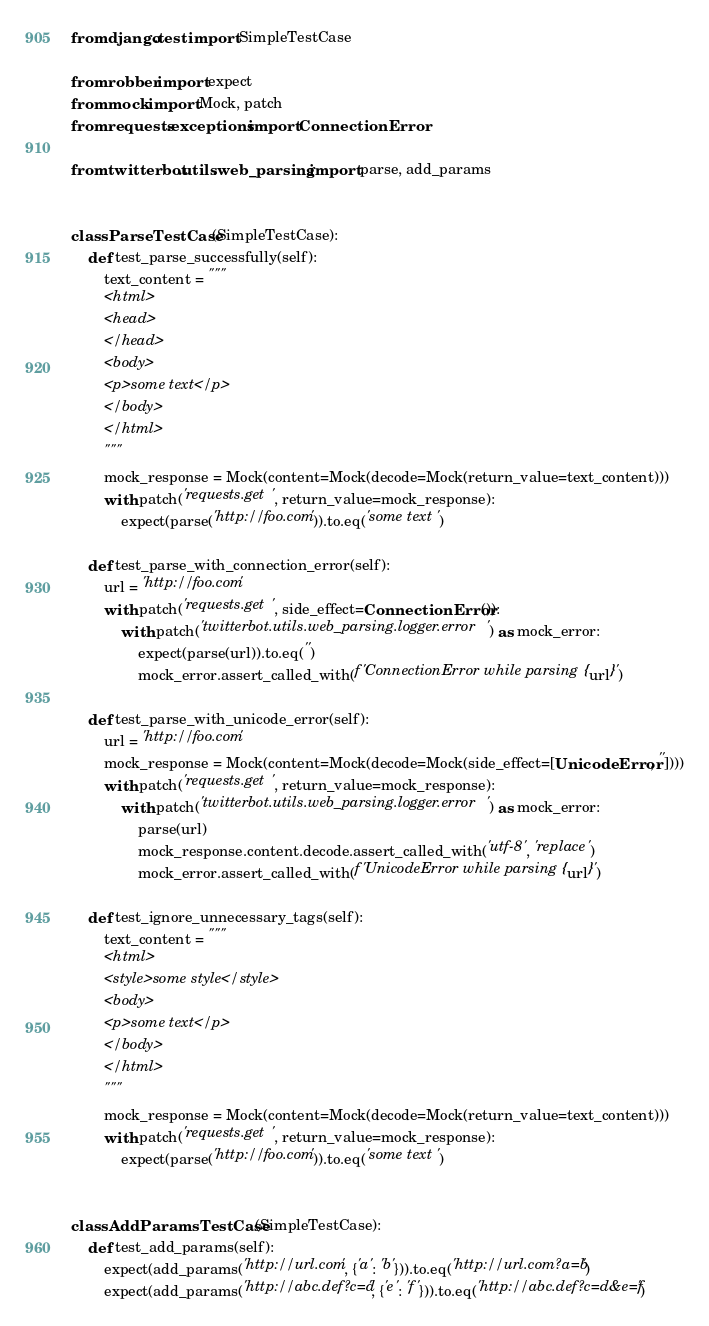<code> <loc_0><loc_0><loc_500><loc_500><_Python_>from django.test import SimpleTestCase

from robber import expect
from mock import Mock, patch
from requests.exceptions import ConnectionError

from twitterbot.utils.web_parsing import parse, add_params


class ParseTestCase(SimpleTestCase):
    def test_parse_successfully(self):
        text_content = """
        <html>
        <head>
        </head>
        <body>
        <p>some text</p>
        </body>
        </html>
        """
        mock_response = Mock(content=Mock(decode=Mock(return_value=text_content)))
        with patch('requests.get', return_value=mock_response):
            expect(parse('http://foo.com')).to.eq('some text')

    def test_parse_with_connection_error(self):
        url = 'http://foo.com'
        with patch('requests.get', side_effect=ConnectionError()):
            with patch('twitterbot.utils.web_parsing.logger.error') as mock_error:
                expect(parse(url)).to.eq('')
                mock_error.assert_called_with(f'ConnectionError while parsing {url}')

    def test_parse_with_unicode_error(self):
        url = 'http://foo.com'
        mock_response = Mock(content=Mock(decode=Mock(side_effect=[UnicodeError, ''])))
        with patch('requests.get', return_value=mock_response):
            with patch('twitterbot.utils.web_parsing.logger.error') as mock_error:
                parse(url)
                mock_response.content.decode.assert_called_with('utf-8', 'replace')
                mock_error.assert_called_with(f'UnicodeError while parsing {url}')

    def test_ignore_unnecessary_tags(self):
        text_content = """
        <html>
        <style>some style</style>
        <body>
        <p>some text</p>
        </body>
        </html>
        """
        mock_response = Mock(content=Mock(decode=Mock(return_value=text_content)))
        with patch('requests.get', return_value=mock_response):
            expect(parse('http://foo.com')).to.eq('some text')


class AddParamsTestCase(SimpleTestCase):
    def test_add_params(self):
        expect(add_params('http://url.com', {'a': 'b'})).to.eq('http://url.com?a=b')
        expect(add_params('http://abc.def?c=d', {'e': 'f'})).to.eq('http://abc.def?c=d&e=f')
</code> 